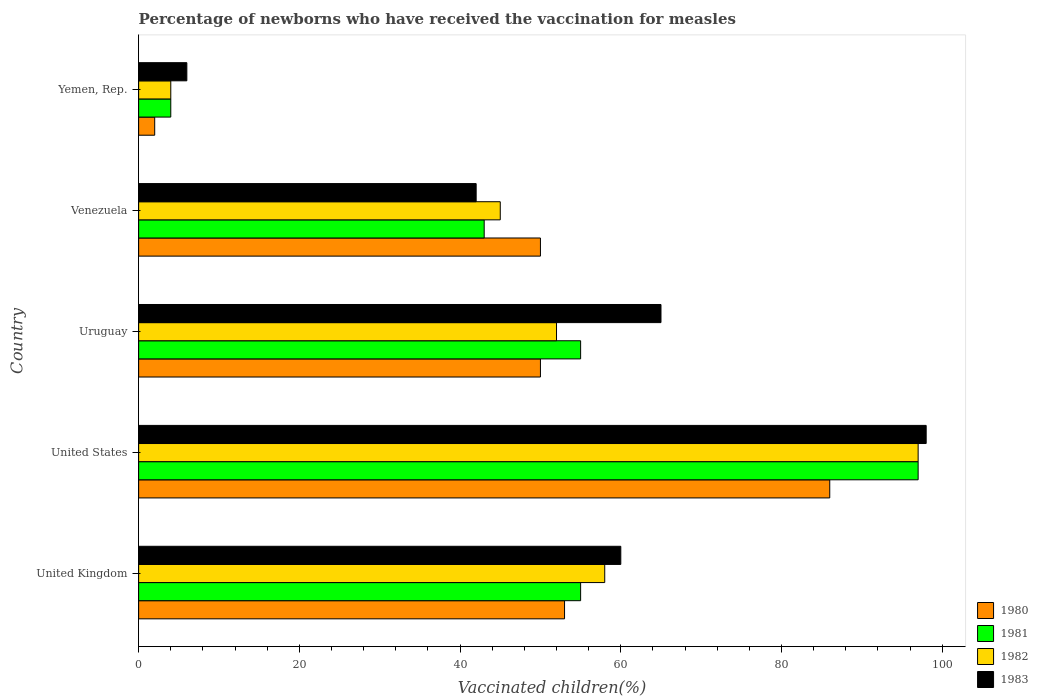Are the number of bars on each tick of the Y-axis equal?
Your answer should be very brief. Yes. How many bars are there on the 5th tick from the top?
Ensure brevity in your answer.  4. What is the label of the 3rd group of bars from the top?
Offer a very short reply. Uruguay. Across all countries, what is the maximum percentage of vaccinated children in 1981?
Keep it short and to the point. 97. Across all countries, what is the minimum percentage of vaccinated children in 1981?
Your response must be concise. 4. In which country was the percentage of vaccinated children in 1981 maximum?
Make the answer very short. United States. In which country was the percentage of vaccinated children in 1982 minimum?
Make the answer very short. Yemen, Rep. What is the total percentage of vaccinated children in 1983 in the graph?
Provide a succinct answer. 271. What is the difference between the percentage of vaccinated children in 1982 in Uruguay and that in Yemen, Rep.?
Keep it short and to the point. 48. What is the difference between the percentage of vaccinated children in 1981 in Yemen, Rep. and the percentage of vaccinated children in 1980 in Venezuela?
Your answer should be compact. -46. What is the average percentage of vaccinated children in 1981 per country?
Offer a terse response. 50.8. In how many countries, is the percentage of vaccinated children in 1982 greater than 60 %?
Your answer should be compact. 1. What is the ratio of the percentage of vaccinated children in 1981 in United Kingdom to that in Venezuela?
Provide a succinct answer. 1.28. Is the percentage of vaccinated children in 1982 in Venezuela less than that in Yemen, Rep.?
Provide a succinct answer. No. What is the difference between the highest and the second highest percentage of vaccinated children in 1980?
Offer a terse response. 33. What is the difference between the highest and the lowest percentage of vaccinated children in 1981?
Keep it short and to the point. 93. In how many countries, is the percentage of vaccinated children in 1983 greater than the average percentage of vaccinated children in 1983 taken over all countries?
Provide a succinct answer. 3. What does the 3rd bar from the bottom in United Kingdom represents?
Make the answer very short. 1982. How many bars are there?
Offer a terse response. 20. Does the graph contain grids?
Provide a short and direct response. No. How many legend labels are there?
Offer a very short reply. 4. How are the legend labels stacked?
Offer a very short reply. Vertical. What is the title of the graph?
Provide a succinct answer. Percentage of newborns who have received the vaccination for measles. What is the label or title of the X-axis?
Ensure brevity in your answer.  Vaccinated children(%). What is the Vaccinated children(%) of 1980 in United Kingdom?
Keep it short and to the point. 53. What is the Vaccinated children(%) in 1981 in United Kingdom?
Provide a succinct answer. 55. What is the Vaccinated children(%) of 1980 in United States?
Your answer should be very brief. 86. What is the Vaccinated children(%) of 1981 in United States?
Your answer should be compact. 97. What is the Vaccinated children(%) in 1982 in United States?
Your answer should be very brief. 97. What is the Vaccinated children(%) of 1981 in Venezuela?
Your answer should be very brief. 43. What is the Vaccinated children(%) of 1980 in Yemen, Rep.?
Your response must be concise. 2. What is the Vaccinated children(%) in 1982 in Yemen, Rep.?
Offer a very short reply. 4. Across all countries, what is the maximum Vaccinated children(%) in 1981?
Your response must be concise. 97. Across all countries, what is the maximum Vaccinated children(%) in 1982?
Your response must be concise. 97. Across all countries, what is the minimum Vaccinated children(%) in 1980?
Ensure brevity in your answer.  2. Across all countries, what is the minimum Vaccinated children(%) in 1981?
Offer a very short reply. 4. Across all countries, what is the minimum Vaccinated children(%) in 1982?
Your response must be concise. 4. What is the total Vaccinated children(%) in 1980 in the graph?
Ensure brevity in your answer.  241. What is the total Vaccinated children(%) of 1981 in the graph?
Provide a short and direct response. 254. What is the total Vaccinated children(%) of 1982 in the graph?
Your response must be concise. 256. What is the total Vaccinated children(%) in 1983 in the graph?
Provide a succinct answer. 271. What is the difference between the Vaccinated children(%) of 1980 in United Kingdom and that in United States?
Your answer should be compact. -33. What is the difference between the Vaccinated children(%) of 1981 in United Kingdom and that in United States?
Offer a very short reply. -42. What is the difference between the Vaccinated children(%) of 1982 in United Kingdom and that in United States?
Make the answer very short. -39. What is the difference between the Vaccinated children(%) in 1983 in United Kingdom and that in United States?
Provide a short and direct response. -38. What is the difference between the Vaccinated children(%) in 1980 in United Kingdom and that in Uruguay?
Your response must be concise. 3. What is the difference between the Vaccinated children(%) of 1981 in United Kingdom and that in Uruguay?
Provide a short and direct response. 0. What is the difference between the Vaccinated children(%) of 1982 in United Kingdom and that in Uruguay?
Provide a short and direct response. 6. What is the difference between the Vaccinated children(%) in 1983 in United Kingdom and that in Uruguay?
Give a very brief answer. -5. What is the difference between the Vaccinated children(%) of 1980 in United Kingdom and that in Venezuela?
Provide a short and direct response. 3. What is the difference between the Vaccinated children(%) of 1981 in United Kingdom and that in Yemen, Rep.?
Ensure brevity in your answer.  51. What is the difference between the Vaccinated children(%) in 1983 in United Kingdom and that in Yemen, Rep.?
Keep it short and to the point. 54. What is the difference between the Vaccinated children(%) in 1980 in United States and that in Uruguay?
Your response must be concise. 36. What is the difference between the Vaccinated children(%) in 1982 in United States and that in Uruguay?
Provide a succinct answer. 45. What is the difference between the Vaccinated children(%) in 1983 in United States and that in Uruguay?
Make the answer very short. 33. What is the difference between the Vaccinated children(%) in 1981 in United States and that in Yemen, Rep.?
Give a very brief answer. 93. What is the difference between the Vaccinated children(%) in 1982 in United States and that in Yemen, Rep.?
Provide a short and direct response. 93. What is the difference between the Vaccinated children(%) of 1983 in United States and that in Yemen, Rep.?
Your response must be concise. 92. What is the difference between the Vaccinated children(%) in 1980 in Uruguay and that in Venezuela?
Your answer should be compact. 0. What is the difference between the Vaccinated children(%) in 1983 in Uruguay and that in Venezuela?
Keep it short and to the point. 23. What is the difference between the Vaccinated children(%) of 1981 in Uruguay and that in Yemen, Rep.?
Your response must be concise. 51. What is the difference between the Vaccinated children(%) of 1983 in Uruguay and that in Yemen, Rep.?
Offer a very short reply. 59. What is the difference between the Vaccinated children(%) of 1980 in Venezuela and that in Yemen, Rep.?
Offer a very short reply. 48. What is the difference between the Vaccinated children(%) in 1981 in Venezuela and that in Yemen, Rep.?
Your answer should be compact. 39. What is the difference between the Vaccinated children(%) in 1983 in Venezuela and that in Yemen, Rep.?
Provide a succinct answer. 36. What is the difference between the Vaccinated children(%) in 1980 in United Kingdom and the Vaccinated children(%) in 1981 in United States?
Offer a very short reply. -44. What is the difference between the Vaccinated children(%) of 1980 in United Kingdom and the Vaccinated children(%) of 1982 in United States?
Provide a short and direct response. -44. What is the difference between the Vaccinated children(%) in 1980 in United Kingdom and the Vaccinated children(%) in 1983 in United States?
Provide a succinct answer. -45. What is the difference between the Vaccinated children(%) in 1981 in United Kingdom and the Vaccinated children(%) in 1982 in United States?
Offer a terse response. -42. What is the difference between the Vaccinated children(%) in 1981 in United Kingdom and the Vaccinated children(%) in 1983 in United States?
Your answer should be compact. -43. What is the difference between the Vaccinated children(%) in 1982 in United Kingdom and the Vaccinated children(%) in 1983 in United States?
Offer a very short reply. -40. What is the difference between the Vaccinated children(%) in 1980 in United Kingdom and the Vaccinated children(%) in 1981 in Uruguay?
Provide a succinct answer. -2. What is the difference between the Vaccinated children(%) of 1980 in United Kingdom and the Vaccinated children(%) of 1982 in Uruguay?
Make the answer very short. 1. What is the difference between the Vaccinated children(%) of 1981 in United Kingdom and the Vaccinated children(%) of 1983 in Uruguay?
Provide a succinct answer. -10. What is the difference between the Vaccinated children(%) of 1980 in United Kingdom and the Vaccinated children(%) of 1981 in Venezuela?
Give a very brief answer. 10. What is the difference between the Vaccinated children(%) in 1980 in United Kingdom and the Vaccinated children(%) in 1982 in Venezuela?
Provide a short and direct response. 8. What is the difference between the Vaccinated children(%) in 1980 in United Kingdom and the Vaccinated children(%) in 1983 in Venezuela?
Provide a succinct answer. 11. What is the difference between the Vaccinated children(%) in 1981 in United Kingdom and the Vaccinated children(%) in 1982 in Venezuela?
Your response must be concise. 10. What is the difference between the Vaccinated children(%) in 1981 in United Kingdom and the Vaccinated children(%) in 1983 in Venezuela?
Provide a succinct answer. 13. What is the difference between the Vaccinated children(%) of 1982 in United Kingdom and the Vaccinated children(%) of 1983 in Venezuela?
Your response must be concise. 16. What is the difference between the Vaccinated children(%) of 1980 in United Kingdom and the Vaccinated children(%) of 1982 in Yemen, Rep.?
Offer a very short reply. 49. What is the difference between the Vaccinated children(%) of 1980 in United Kingdom and the Vaccinated children(%) of 1983 in Yemen, Rep.?
Make the answer very short. 47. What is the difference between the Vaccinated children(%) of 1981 in United Kingdom and the Vaccinated children(%) of 1983 in Yemen, Rep.?
Ensure brevity in your answer.  49. What is the difference between the Vaccinated children(%) of 1980 in United States and the Vaccinated children(%) of 1983 in Uruguay?
Ensure brevity in your answer.  21. What is the difference between the Vaccinated children(%) of 1981 in United States and the Vaccinated children(%) of 1982 in Uruguay?
Your response must be concise. 45. What is the difference between the Vaccinated children(%) of 1982 in United States and the Vaccinated children(%) of 1983 in Uruguay?
Your answer should be very brief. 32. What is the difference between the Vaccinated children(%) in 1980 in United States and the Vaccinated children(%) in 1982 in Venezuela?
Offer a very short reply. 41. What is the difference between the Vaccinated children(%) of 1980 in United States and the Vaccinated children(%) of 1983 in Venezuela?
Keep it short and to the point. 44. What is the difference between the Vaccinated children(%) in 1980 in United States and the Vaccinated children(%) in 1981 in Yemen, Rep.?
Provide a succinct answer. 82. What is the difference between the Vaccinated children(%) in 1980 in United States and the Vaccinated children(%) in 1982 in Yemen, Rep.?
Ensure brevity in your answer.  82. What is the difference between the Vaccinated children(%) of 1980 in United States and the Vaccinated children(%) of 1983 in Yemen, Rep.?
Keep it short and to the point. 80. What is the difference between the Vaccinated children(%) in 1981 in United States and the Vaccinated children(%) in 1982 in Yemen, Rep.?
Provide a succinct answer. 93. What is the difference between the Vaccinated children(%) of 1981 in United States and the Vaccinated children(%) of 1983 in Yemen, Rep.?
Keep it short and to the point. 91. What is the difference between the Vaccinated children(%) in 1982 in United States and the Vaccinated children(%) in 1983 in Yemen, Rep.?
Provide a short and direct response. 91. What is the difference between the Vaccinated children(%) of 1980 in Uruguay and the Vaccinated children(%) of 1981 in Venezuela?
Provide a succinct answer. 7. What is the difference between the Vaccinated children(%) in 1980 in Uruguay and the Vaccinated children(%) in 1982 in Venezuela?
Keep it short and to the point. 5. What is the difference between the Vaccinated children(%) in 1980 in Uruguay and the Vaccinated children(%) in 1983 in Venezuela?
Offer a terse response. 8. What is the difference between the Vaccinated children(%) of 1981 in Uruguay and the Vaccinated children(%) of 1982 in Venezuela?
Offer a terse response. 10. What is the difference between the Vaccinated children(%) of 1981 in Uruguay and the Vaccinated children(%) of 1983 in Venezuela?
Make the answer very short. 13. What is the difference between the Vaccinated children(%) in 1982 in Uruguay and the Vaccinated children(%) in 1983 in Venezuela?
Keep it short and to the point. 10. What is the difference between the Vaccinated children(%) of 1980 in Uruguay and the Vaccinated children(%) of 1981 in Yemen, Rep.?
Your answer should be very brief. 46. What is the difference between the Vaccinated children(%) in 1981 in Uruguay and the Vaccinated children(%) in 1982 in Yemen, Rep.?
Ensure brevity in your answer.  51. What is the difference between the Vaccinated children(%) of 1982 in Uruguay and the Vaccinated children(%) of 1983 in Yemen, Rep.?
Provide a short and direct response. 46. What is the difference between the Vaccinated children(%) of 1980 in Venezuela and the Vaccinated children(%) of 1982 in Yemen, Rep.?
Make the answer very short. 46. What is the difference between the Vaccinated children(%) of 1981 in Venezuela and the Vaccinated children(%) of 1982 in Yemen, Rep.?
Your response must be concise. 39. What is the average Vaccinated children(%) in 1980 per country?
Provide a short and direct response. 48.2. What is the average Vaccinated children(%) in 1981 per country?
Offer a terse response. 50.8. What is the average Vaccinated children(%) of 1982 per country?
Provide a short and direct response. 51.2. What is the average Vaccinated children(%) of 1983 per country?
Offer a very short reply. 54.2. What is the difference between the Vaccinated children(%) in 1980 and Vaccinated children(%) in 1981 in United Kingdom?
Make the answer very short. -2. What is the difference between the Vaccinated children(%) in 1980 and Vaccinated children(%) in 1983 in United Kingdom?
Your response must be concise. -7. What is the difference between the Vaccinated children(%) in 1981 and Vaccinated children(%) in 1983 in United Kingdom?
Keep it short and to the point. -5. What is the difference between the Vaccinated children(%) in 1982 and Vaccinated children(%) in 1983 in United Kingdom?
Your answer should be very brief. -2. What is the difference between the Vaccinated children(%) in 1980 and Vaccinated children(%) in 1981 in United States?
Offer a very short reply. -11. What is the difference between the Vaccinated children(%) in 1982 and Vaccinated children(%) in 1983 in United States?
Offer a very short reply. -1. What is the difference between the Vaccinated children(%) in 1980 and Vaccinated children(%) in 1981 in Uruguay?
Provide a short and direct response. -5. What is the difference between the Vaccinated children(%) of 1980 and Vaccinated children(%) of 1982 in Uruguay?
Provide a succinct answer. -2. What is the difference between the Vaccinated children(%) of 1980 and Vaccinated children(%) of 1983 in Uruguay?
Your answer should be compact. -15. What is the difference between the Vaccinated children(%) of 1981 and Vaccinated children(%) of 1982 in Uruguay?
Provide a succinct answer. 3. What is the difference between the Vaccinated children(%) of 1981 and Vaccinated children(%) of 1983 in Uruguay?
Make the answer very short. -10. What is the difference between the Vaccinated children(%) in 1982 and Vaccinated children(%) in 1983 in Uruguay?
Provide a short and direct response. -13. What is the difference between the Vaccinated children(%) of 1980 and Vaccinated children(%) of 1981 in Venezuela?
Keep it short and to the point. 7. What is the difference between the Vaccinated children(%) in 1982 and Vaccinated children(%) in 1983 in Venezuela?
Offer a terse response. 3. What is the difference between the Vaccinated children(%) in 1980 and Vaccinated children(%) in 1981 in Yemen, Rep.?
Ensure brevity in your answer.  -2. What is the difference between the Vaccinated children(%) in 1980 and Vaccinated children(%) in 1983 in Yemen, Rep.?
Provide a short and direct response. -4. What is the difference between the Vaccinated children(%) of 1981 and Vaccinated children(%) of 1983 in Yemen, Rep.?
Your response must be concise. -2. What is the ratio of the Vaccinated children(%) of 1980 in United Kingdom to that in United States?
Your answer should be very brief. 0.62. What is the ratio of the Vaccinated children(%) in 1981 in United Kingdom to that in United States?
Make the answer very short. 0.57. What is the ratio of the Vaccinated children(%) in 1982 in United Kingdom to that in United States?
Make the answer very short. 0.6. What is the ratio of the Vaccinated children(%) of 1983 in United Kingdom to that in United States?
Your answer should be very brief. 0.61. What is the ratio of the Vaccinated children(%) in 1980 in United Kingdom to that in Uruguay?
Give a very brief answer. 1.06. What is the ratio of the Vaccinated children(%) of 1982 in United Kingdom to that in Uruguay?
Offer a very short reply. 1.12. What is the ratio of the Vaccinated children(%) of 1983 in United Kingdom to that in Uruguay?
Provide a short and direct response. 0.92. What is the ratio of the Vaccinated children(%) of 1980 in United Kingdom to that in Venezuela?
Provide a succinct answer. 1.06. What is the ratio of the Vaccinated children(%) in 1981 in United Kingdom to that in Venezuela?
Your answer should be very brief. 1.28. What is the ratio of the Vaccinated children(%) of 1982 in United Kingdom to that in Venezuela?
Provide a short and direct response. 1.29. What is the ratio of the Vaccinated children(%) in 1983 in United Kingdom to that in Venezuela?
Offer a very short reply. 1.43. What is the ratio of the Vaccinated children(%) in 1980 in United Kingdom to that in Yemen, Rep.?
Offer a very short reply. 26.5. What is the ratio of the Vaccinated children(%) of 1981 in United Kingdom to that in Yemen, Rep.?
Your answer should be very brief. 13.75. What is the ratio of the Vaccinated children(%) in 1982 in United Kingdom to that in Yemen, Rep.?
Offer a very short reply. 14.5. What is the ratio of the Vaccinated children(%) in 1983 in United Kingdom to that in Yemen, Rep.?
Your answer should be compact. 10. What is the ratio of the Vaccinated children(%) in 1980 in United States to that in Uruguay?
Make the answer very short. 1.72. What is the ratio of the Vaccinated children(%) of 1981 in United States to that in Uruguay?
Offer a terse response. 1.76. What is the ratio of the Vaccinated children(%) in 1982 in United States to that in Uruguay?
Give a very brief answer. 1.87. What is the ratio of the Vaccinated children(%) of 1983 in United States to that in Uruguay?
Your answer should be very brief. 1.51. What is the ratio of the Vaccinated children(%) in 1980 in United States to that in Venezuela?
Keep it short and to the point. 1.72. What is the ratio of the Vaccinated children(%) of 1981 in United States to that in Venezuela?
Make the answer very short. 2.26. What is the ratio of the Vaccinated children(%) of 1982 in United States to that in Venezuela?
Offer a very short reply. 2.16. What is the ratio of the Vaccinated children(%) in 1983 in United States to that in Venezuela?
Give a very brief answer. 2.33. What is the ratio of the Vaccinated children(%) of 1981 in United States to that in Yemen, Rep.?
Give a very brief answer. 24.25. What is the ratio of the Vaccinated children(%) of 1982 in United States to that in Yemen, Rep.?
Offer a terse response. 24.25. What is the ratio of the Vaccinated children(%) in 1983 in United States to that in Yemen, Rep.?
Keep it short and to the point. 16.33. What is the ratio of the Vaccinated children(%) of 1980 in Uruguay to that in Venezuela?
Make the answer very short. 1. What is the ratio of the Vaccinated children(%) in 1981 in Uruguay to that in Venezuela?
Offer a very short reply. 1.28. What is the ratio of the Vaccinated children(%) in 1982 in Uruguay to that in Venezuela?
Your answer should be compact. 1.16. What is the ratio of the Vaccinated children(%) of 1983 in Uruguay to that in Venezuela?
Provide a succinct answer. 1.55. What is the ratio of the Vaccinated children(%) in 1981 in Uruguay to that in Yemen, Rep.?
Give a very brief answer. 13.75. What is the ratio of the Vaccinated children(%) of 1983 in Uruguay to that in Yemen, Rep.?
Your answer should be compact. 10.83. What is the ratio of the Vaccinated children(%) of 1980 in Venezuela to that in Yemen, Rep.?
Your response must be concise. 25. What is the ratio of the Vaccinated children(%) in 1981 in Venezuela to that in Yemen, Rep.?
Make the answer very short. 10.75. What is the ratio of the Vaccinated children(%) of 1982 in Venezuela to that in Yemen, Rep.?
Your answer should be very brief. 11.25. What is the difference between the highest and the second highest Vaccinated children(%) in 1980?
Ensure brevity in your answer.  33. What is the difference between the highest and the second highest Vaccinated children(%) of 1981?
Your answer should be very brief. 42. What is the difference between the highest and the lowest Vaccinated children(%) in 1980?
Your response must be concise. 84. What is the difference between the highest and the lowest Vaccinated children(%) of 1981?
Offer a very short reply. 93. What is the difference between the highest and the lowest Vaccinated children(%) of 1982?
Ensure brevity in your answer.  93. What is the difference between the highest and the lowest Vaccinated children(%) of 1983?
Give a very brief answer. 92. 